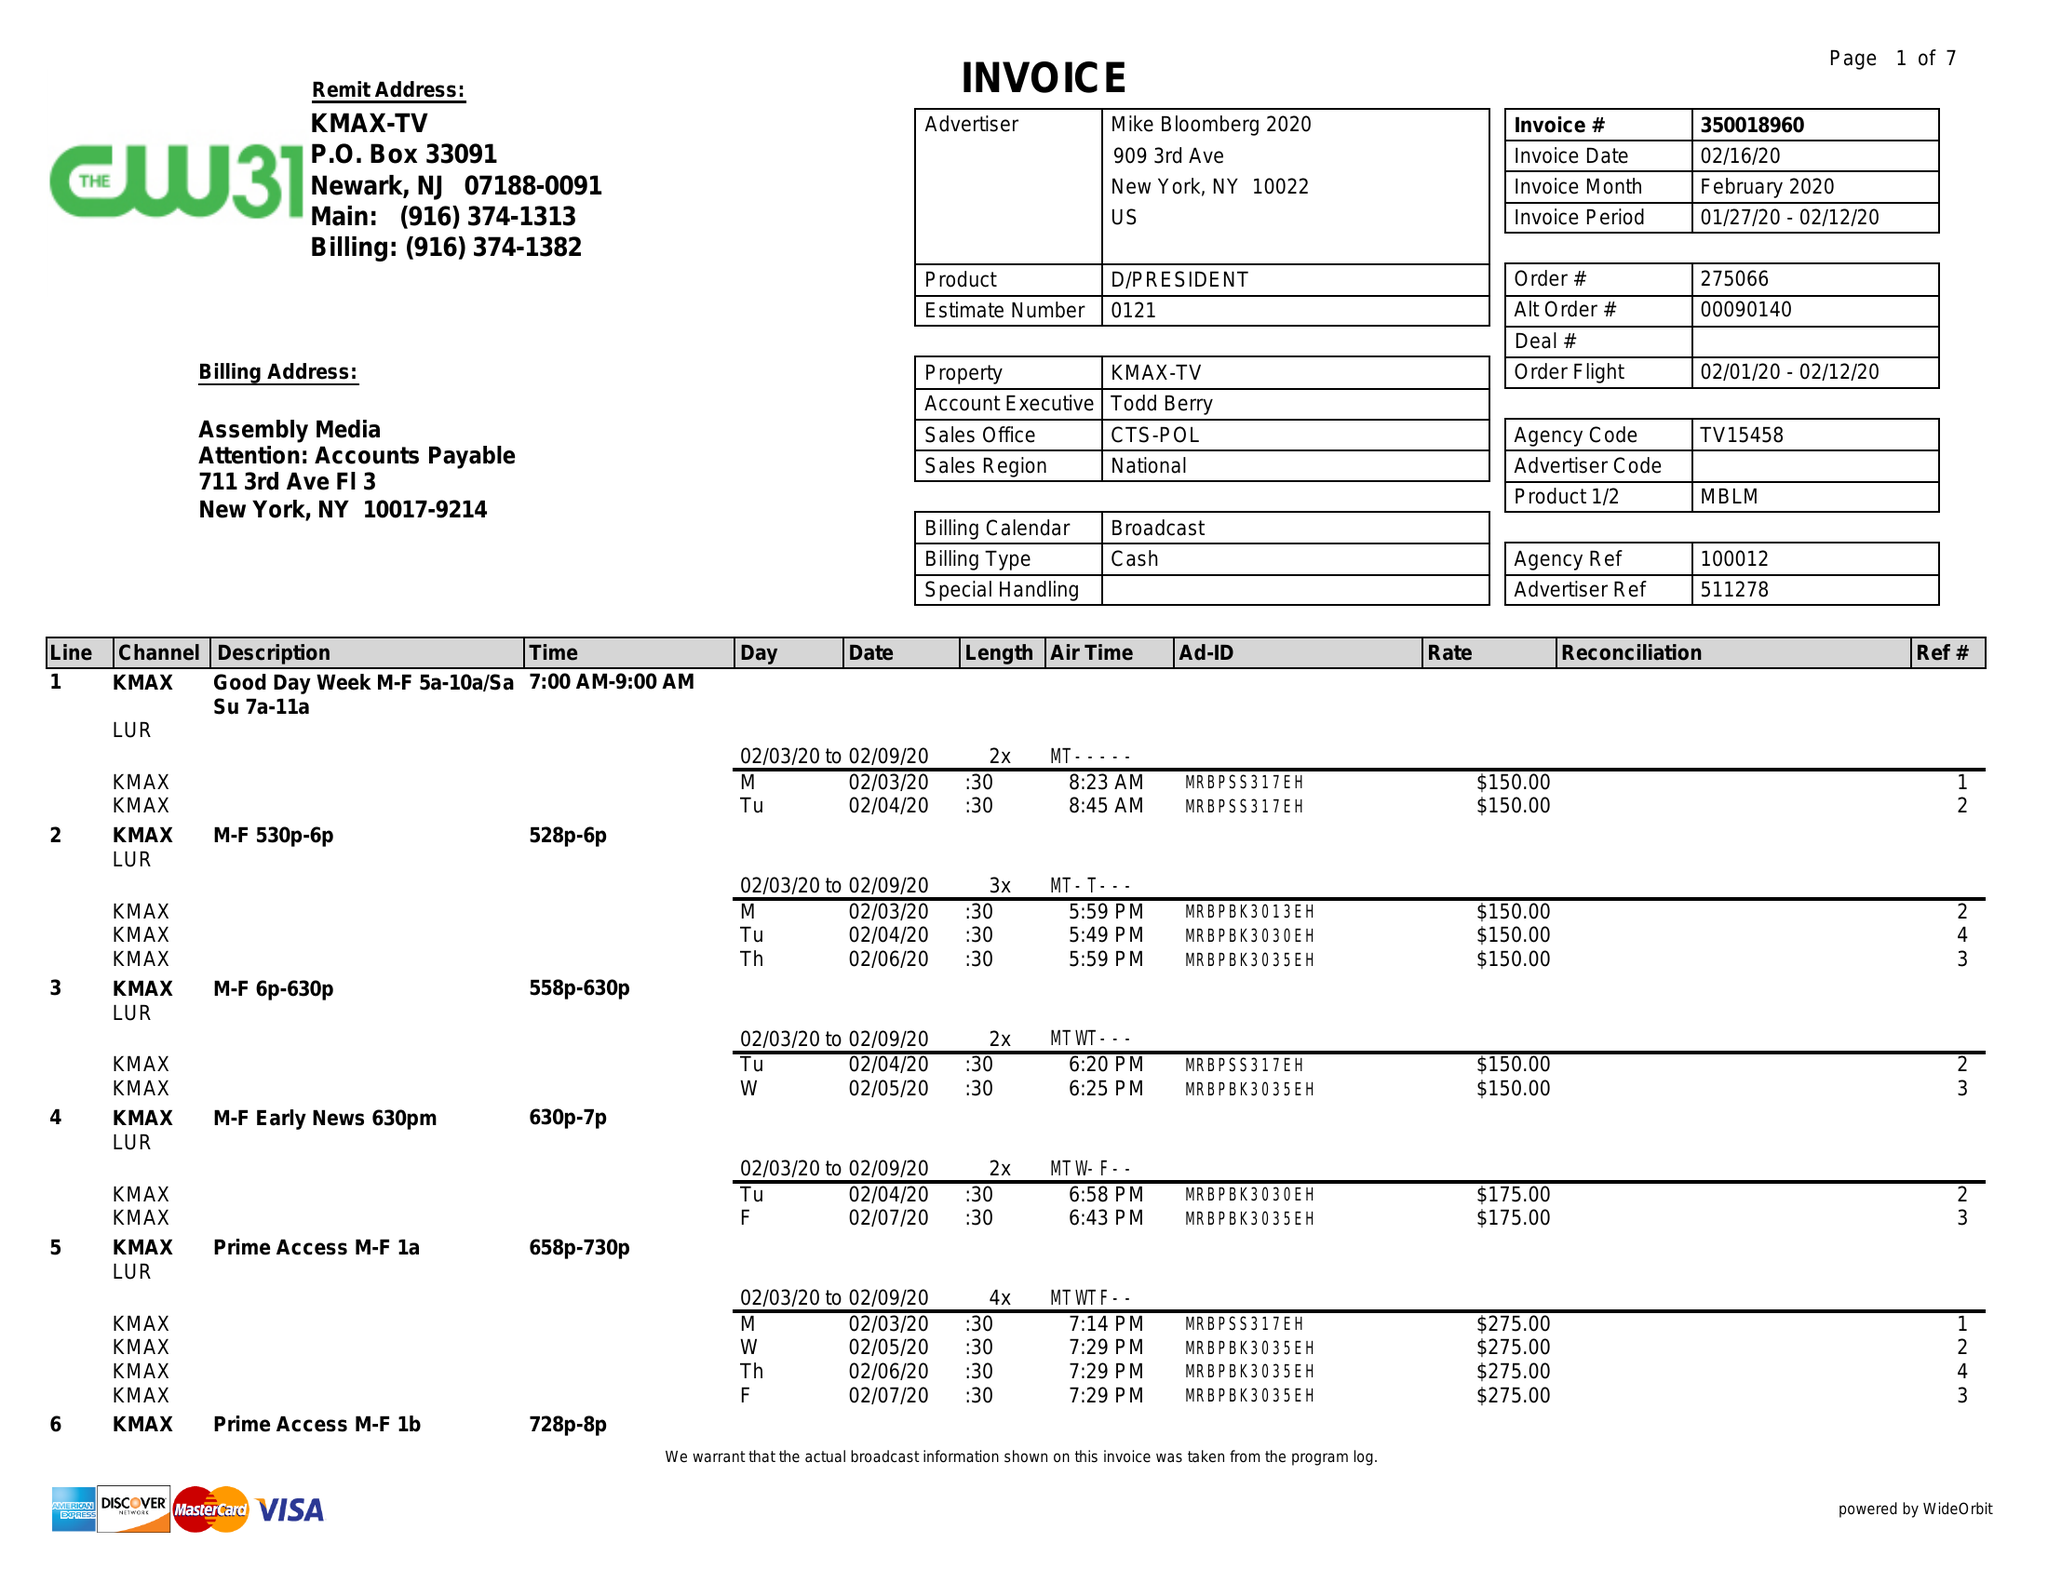What is the value for the contract_num?
Answer the question using a single word or phrase. 350018960 